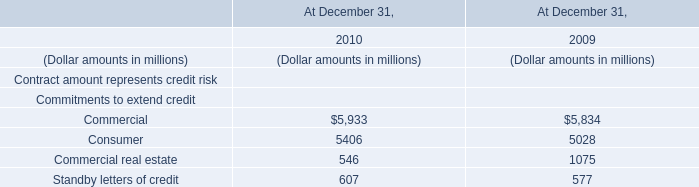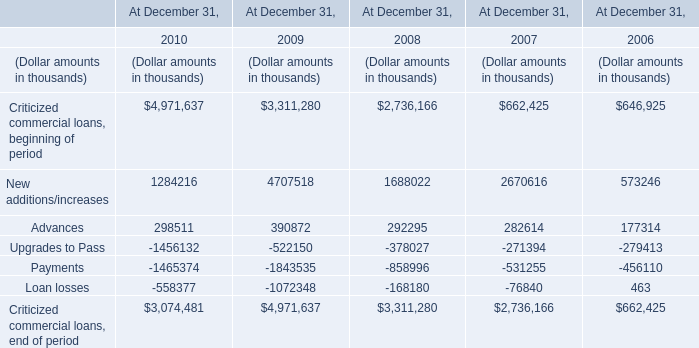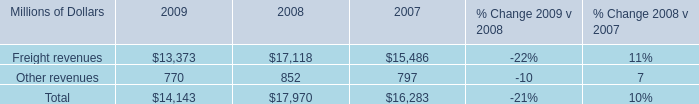What is the sum of Criticized commercial loans, beginning of period, New additions/increases and Advances in 2009? (in thousand) 
Computations: ((3311280 + 4707518) + 390872)
Answer: 8409670.0. 